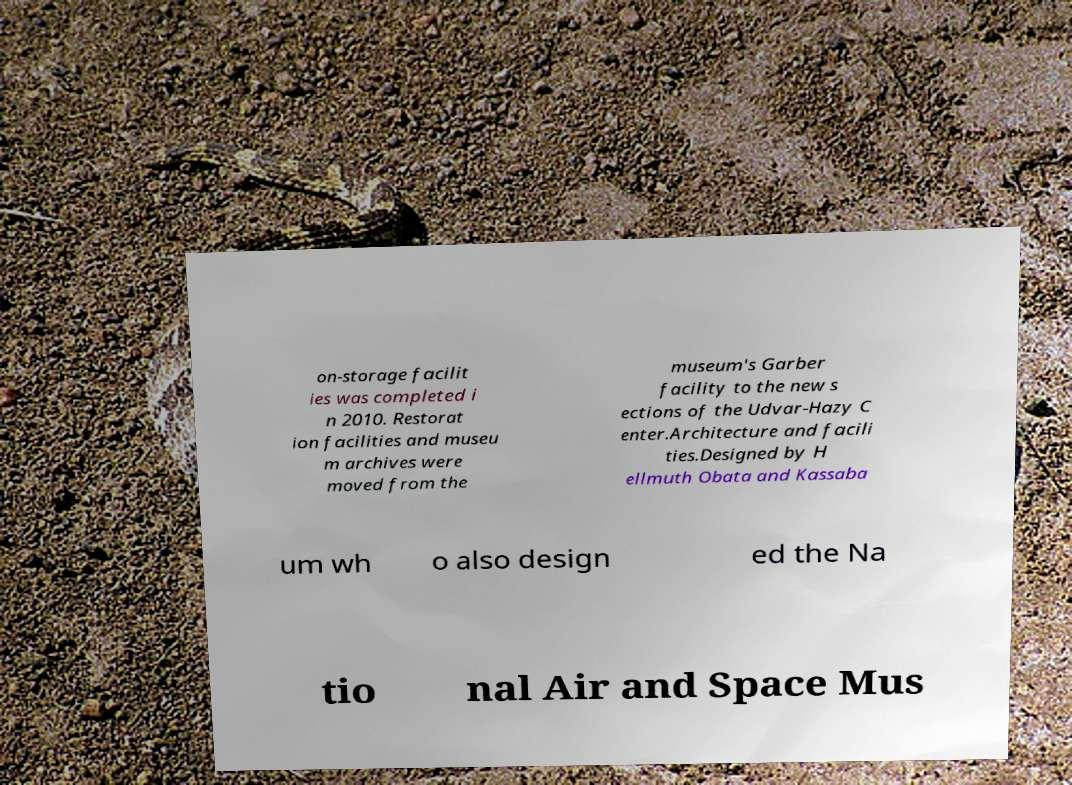Please identify and transcribe the text found in this image. on-storage facilit ies was completed i n 2010. Restorat ion facilities and museu m archives were moved from the museum's Garber facility to the new s ections of the Udvar-Hazy C enter.Architecture and facili ties.Designed by H ellmuth Obata and Kassaba um wh o also design ed the Na tio nal Air and Space Mus 